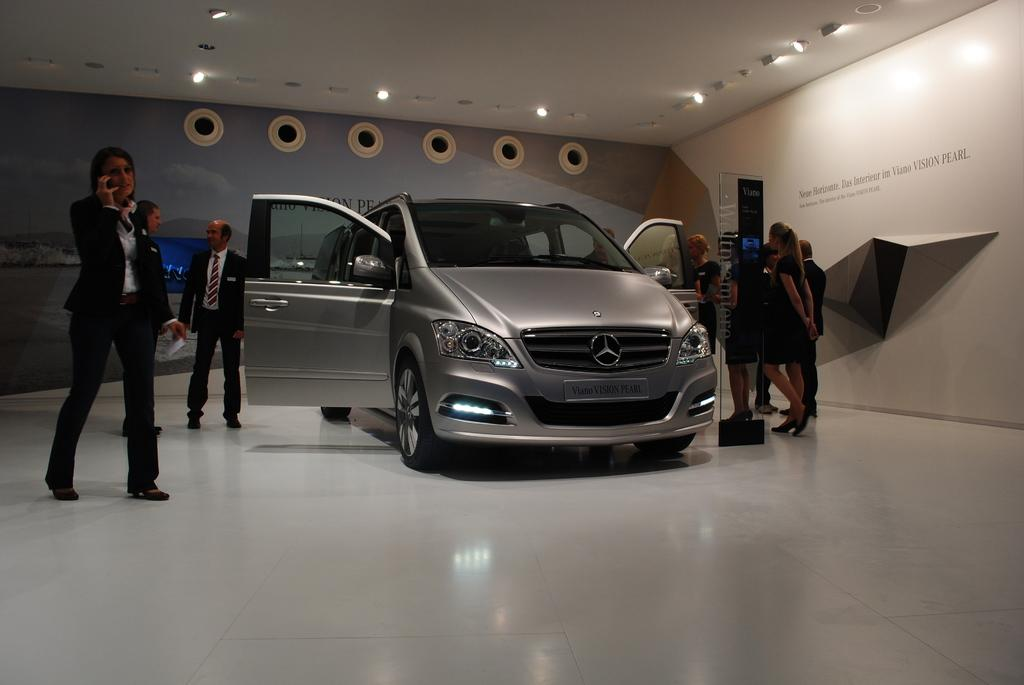What is the state of the vehicle doors in the image? The vehicle doors are open. Are there any people near the vehicle? Yes, there are people beside the vehicle. What can be seen in the image that provides illumination? There are lights visible in the image. What type of collar is being worn by the wheel in the image? There is no wheel or collar present in the image. 